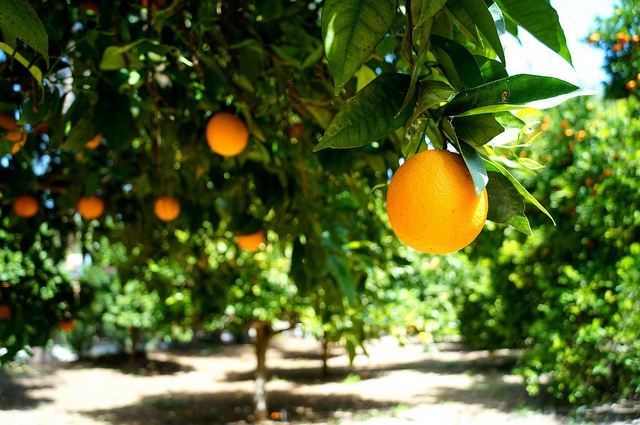Describe the objects in this image and their specific colors. I can see orange in darkgreen, orange, gold, and red tones, orange in darkgreen, orange, brown, and maroon tones, orange in darkgreen, orange, brown, and maroon tones, orange in darkgreen, orange, brown, and maroon tones, and orange in darkgreen, maroon, and brown tones in this image. 